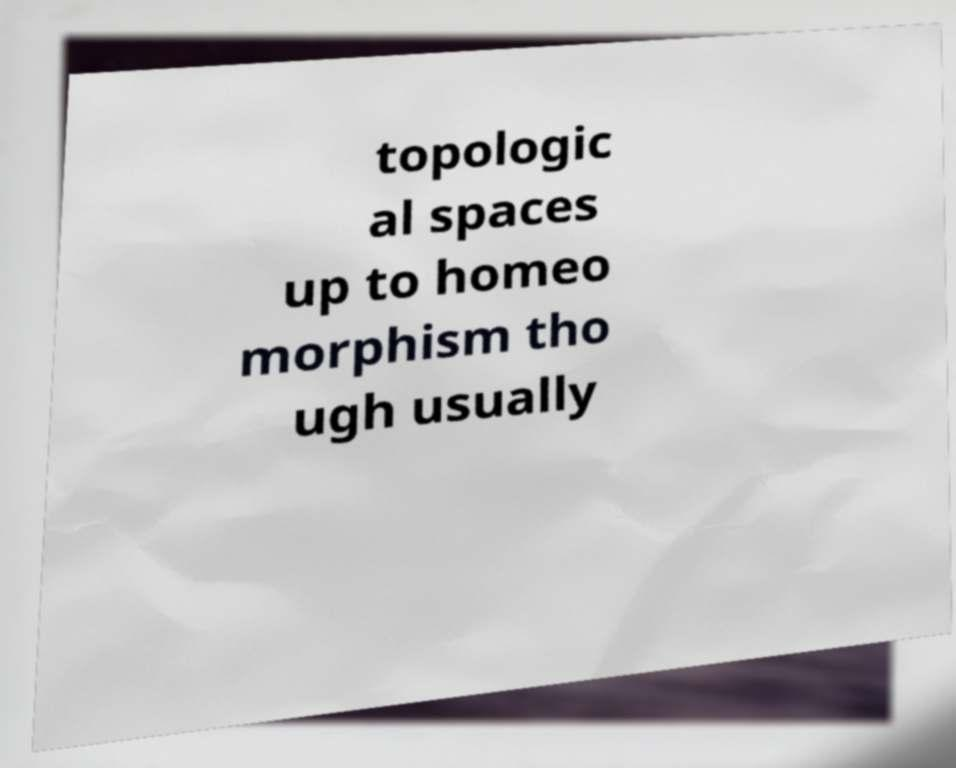Please identify and transcribe the text found in this image. topologic al spaces up to homeo morphism tho ugh usually 